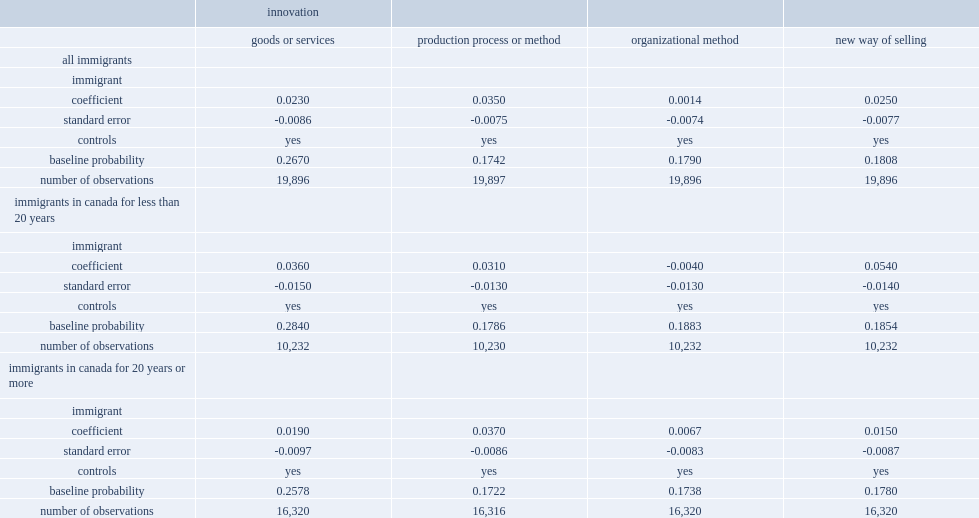For all firms with immigrant owners, what was the percentage points of likelihood of implementing a product innovation higher than for firms with canadian-born owners? 0.023. For process innovations, what was the percentage points of the likelihood higher for immigrant-owned firms? 0.035. What was the percentage points of firms with immigrant owners who had been in canada for more than 20 years were also more likely to implement a process innovation than firms with canadian-born owners? 0.037. 